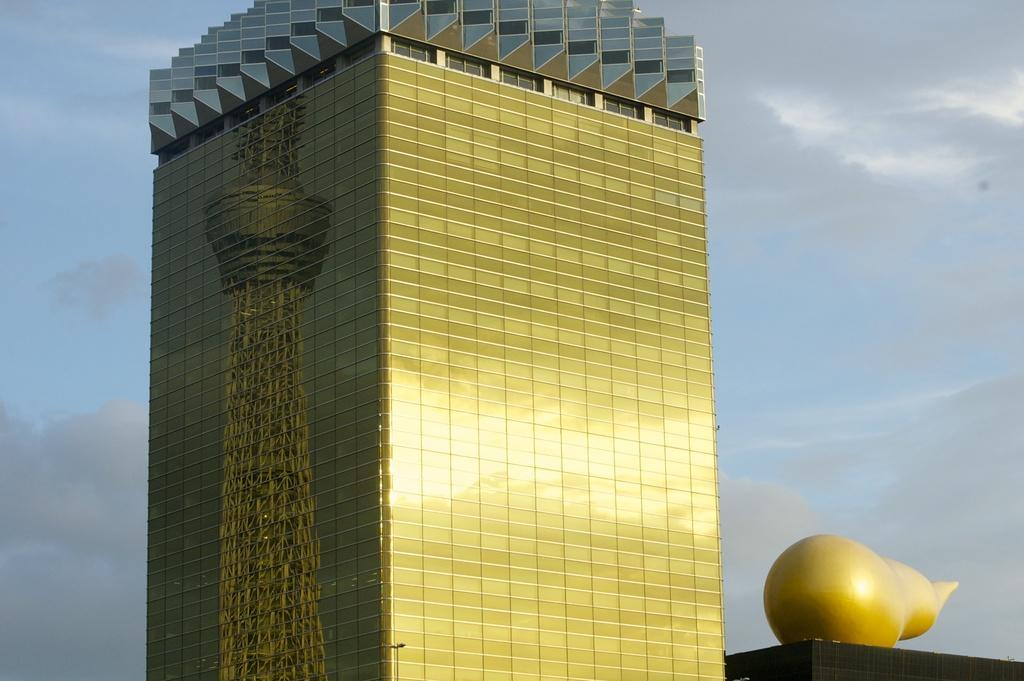What type of structures can be seen in the image? There are buildings in the image. What part of the natural environment is visible in the image? The sky is visible in the image. What can be observed in the sky? Clouds are present in the sky. Where is the drain located in the image? There is no drain present in the image. What word is written on the side of the building in the image? There is no text visible on the buildings in the image. Can you see a chicken in the image? There is no chicken present in the image. 